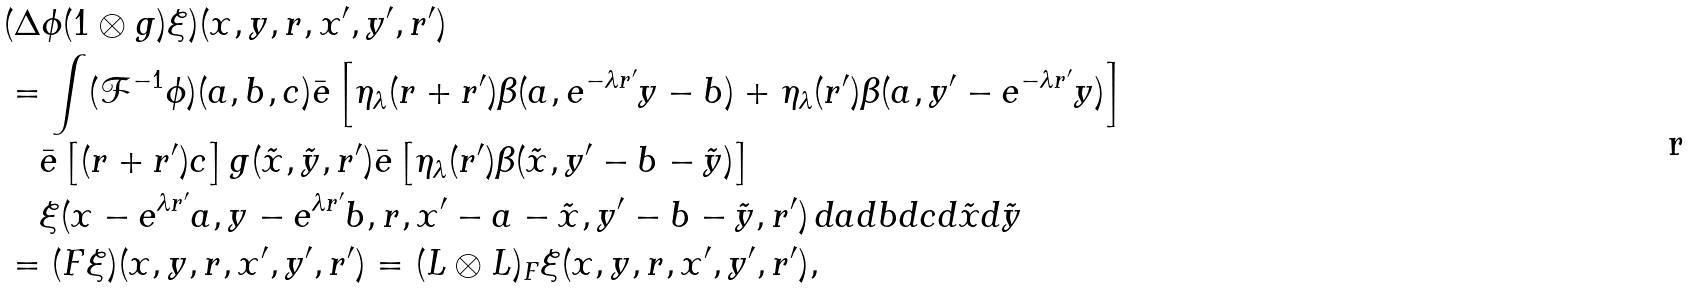<formula> <loc_0><loc_0><loc_500><loc_500>& ( \Delta \phi ( 1 \otimes g ) \xi ) ( x , y , r , x ^ { \prime } , y ^ { \prime } , r ^ { \prime } ) \\ & = \int ( { \mathcal { F } } ^ { - 1 } \phi ) ( a , b , c ) \bar { e } \left [ \eta _ { \lambda } ( r + r ^ { \prime } ) \beta ( a , e ^ { - \lambda r ^ { \prime } } y - b ) + \eta _ { \lambda } ( r ^ { \prime } ) \beta ( a , y ^ { \prime } - e ^ { - \lambda r ^ { \prime } } y ) \right ] \\ & \quad \bar { e } \left [ ( r + r ^ { \prime } ) c \right ] g ( \tilde { x } , \tilde { y } , r ^ { \prime } ) \bar { e } \left [ \eta _ { \lambda } ( r ^ { \prime } ) \beta ( \tilde { x } , y ^ { \prime } - b - \tilde { y } ) \right ] \\ & \quad \xi ( x - e ^ { \lambda r ^ { \prime } } a , y - e ^ { \lambda r ^ { \prime } } b , r , x ^ { \prime } - a - \tilde { x } , y ^ { \prime } - b - \tilde { y } , r ^ { \prime } ) \, d a d b d c d \tilde { x } d \tilde { y } \\ & = ( F \xi ) ( x , y , r , x ^ { \prime } , y ^ { \prime } , r ^ { \prime } ) = ( L \otimes L ) _ { F } \xi ( x , y , r , x ^ { \prime } , y ^ { \prime } , r ^ { \prime } ) ,</formula> 